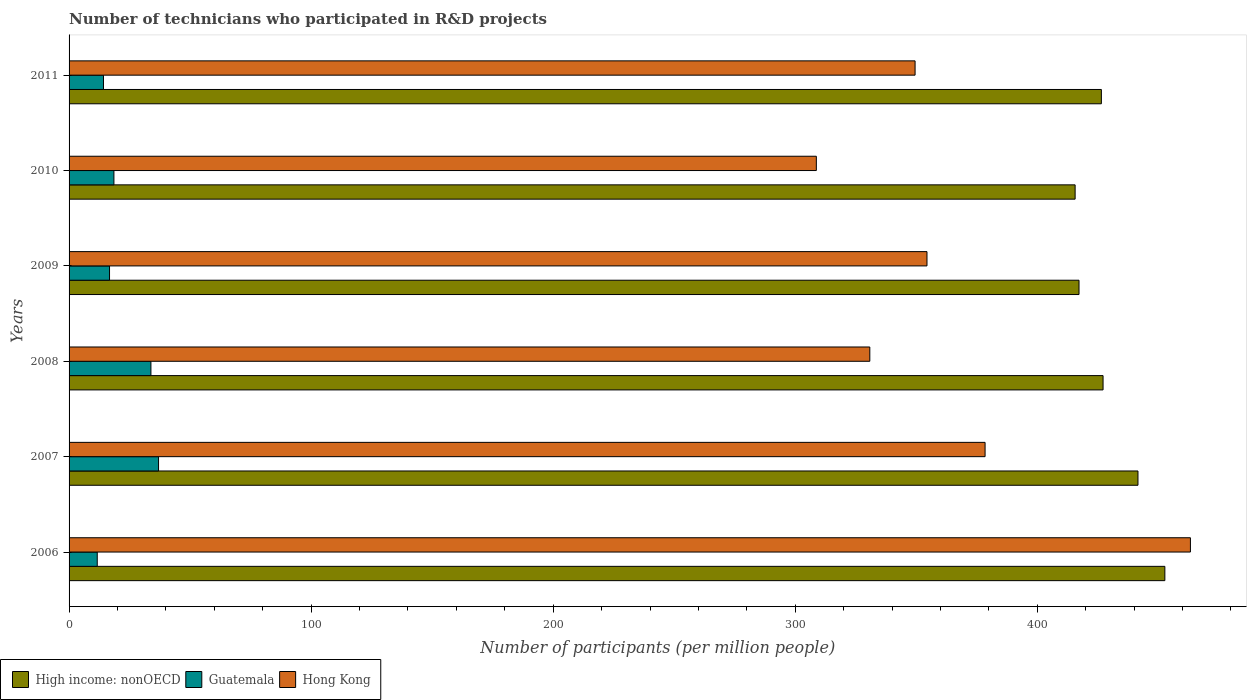Are the number of bars per tick equal to the number of legend labels?
Provide a short and direct response. Yes. How many bars are there on the 2nd tick from the top?
Give a very brief answer. 3. How many bars are there on the 5th tick from the bottom?
Keep it short and to the point. 3. What is the label of the 1st group of bars from the top?
Offer a terse response. 2011. In how many cases, is the number of bars for a given year not equal to the number of legend labels?
Your response must be concise. 0. What is the number of technicians who participated in R&D projects in Hong Kong in 2008?
Ensure brevity in your answer.  330.81. Across all years, what is the maximum number of technicians who participated in R&D projects in Hong Kong?
Your answer should be compact. 463.26. Across all years, what is the minimum number of technicians who participated in R&D projects in High income: nonOECD?
Give a very brief answer. 415.62. In which year was the number of technicians who participated in R&D projects in Hong Kong minimum?
Offer a very short reply. 2010. What is the total number of technicians who participated in R&D projects in High income: nonOECD in the graph?
Ensure brevity in your answer.  2580.78. What is the difference between the number of technicians who participated in R&D projects in Hong Kong in 2007 and that in 2011?
Offer a very short reply. 28.92. What is the difference between the number of technicians who participated in R&D projects in Hong Kong in 2009 and the number of technicians who participated in R&D projects in Guatemala in 2007?
Provide a short and direct response. 317.46. What is the average number of technicians who participated in R&D projects in High income: nonOECD per year?
Provide a succinct answer. 430.13. In the year 2009, what is the difference between the number of technicians who participated in R&D projects in Guatemala and number of technicians who participated in R&D projects in Hong Kong?
Ensure brevity in your answer.  -337.71. In how many years, is the number of technicians who participated in R&D projects in High income: nonOECD greater than 220 ?
Offer a terse response. 6. What is the ratio of the number of technicians who participated in R&D projects in High income: nonOECD in 2009 to that in 2011?
Your answer should be very brief. 0.98. Is the number of technicians who participated in R&D projects in Hong Kong in 2007 less than that in 2011?
Your answer should be compact. No. Is the difference between the number of technicians who participated in R&D projects in Guatemala in 2009 and 2010 greater than the difference between the number of technicians who participated in R&D projects in Hong Kong in 2009 and 2010?
Provide a short and direct response. No. What is the difference between the highest and the second highest number of technicians who participated in R&D projects in Guatemala?
Provide a succinct answer. 3.15. What is the difference between the highest and the lowest number of technicians who participated in R&D projects in High income: nonOECD?
Give a very brief answer. 37.07. What does the 1st bar from the top in 2006 represents?
Your response must be concise. Hong Kong. What does the 1st bar from the bottom in 2006 represents?
Offer a terse response. High income: nonOECD. Is it the case that in every year, the sum of the number of technicians who participated in R&D projects in High income: nonOECD and number of technicians who participated in R&D projects in Guatemala is greater than the number of technicians who participated in R&D projects in Hong Kong?
Offer a very short reply. Yes. Are all the bars in the graph horizontal?
Offer a very short reply. Yes. Are the values on the major ticks of X-axis written in scientific E-notation?
Give a very brief answer. No. Does the graph contain grids?
Offer a terse response. No. How many legend labels are there?
Your answer should be very brief. 3. What is the title of the graph?
Offer a terse response. Number of technicians who participated in R&D projects. What is the label or title of the X-axis?
Your response must be concise. Number of participants (per million people). What is the label or title of the Y-axis?
Offer a terse response. Years. What is the Number of participants (per million people) of High income: nonOECD in 2006?
Your answer should be very brief. 452.7. What is the Number of participants (per million people) in Guatemala in 2006?
Make the answer very short. 11.64. What is the Number of participants (per million people) of Hong Kong in 2006?
Your response must be concise. 463.26. What is the Number of participants (per million people) of High income: nonOECD in 2007?
Offer a terse response. 441.59. What is the Number of participants (per million people) in Guatemala in 2007?
Ensure brevity in your answer.  36.96. What is the Number of participants (per million people) in Hong Kong in 2007?
Offer a very short reply. 378.42. What is the Number of participants (per million people) in High income: nonOECD in 2008?
Provide a succinct answer. 427.17. What is the Number of participants (per million people) in Guatemala in 2008?
Your response must be concise. 33.81. What is the Number of participants (per million people) in Hong Kong in 2008?
Your answer should be very brief. 330.81. What is the Number of participants (per million people) of High income: nonOECD in 2009?
Provide a succinct answer. 417.23. What is the Number of participants (per million people) in Guatemala in 2009?
Your answer should be compact. 16.72. What is the Number of participants (per million people) of Hong Kong in 2009?
Make the answer very short. 354.43. What is the Number of participants (per million people) of High income: nonOECD in 2010?
Your answer should be very brief. 415.62. What is the Number of participants (per million people) of Guatemala in 2010?
Ensure brevity in your answer.  18.53. What is the Number of participants (per million people) of Hong Kong in 2010?
Offer a very short reply. 308.71. What is the Number of participants (per million people) in High income: nonOECD in 2011?
Offer a terse response. 426.47. What is the Number of participants (per million people) of Guatemala in 2011?
Your answer should be very brief. 14.22. What is the Number of participants (per million people) of Hong Kong in 2011?
Your answer should be compact. 349.51. Across all years, what is the maximum Number of participants (per million people) in High income: nonOECD?
Provide a short and direct response. 452.7. Across all years, what is the maximum Number of participants (per million people) in Guatemala?
Your response must be concise. 36.96. Across all years, what is the maximum Number of participants (per million people) in Hong Kong?
Offer a terse response. 463.26. Across all years, what is the minimum Number of participants (per million people) of High income: nonOECD?
Your answer should be compact. 415.62. Across all years, what is the minimum Number of participants (per million people) of Guatemala?
Your answer should be very brief. 11.64. Across all years, what is the minimum Number of participants (per million people) in Hong Kong?
Your answer should be compact. 308.71. What is the total Number of participants (per million people) of High income: nonOECD in the graph?
Make the answer very short. 2580.78. What is the total Number of participants (per million people) of Guatemala in the graph?
Your answer should be compact. 131.88. What is the total Number of participants (per million people) in Hong Kong in the graph?
Provide a succinct answer. 2185.13. What is the difference between the Number of participants (per million people) of High income: nonOECD in 2006 and that in 2007?
Provide a short and direct response. 11.11. What is the difference between the Number of participants (per million people) of Guatemala in 2006 and that in 2007?
Ensure brevity in your answer.  -25.32. What is the difference between the Number of participants (per million people) in Hong Kong in 2006 and that in 2007?
Provide a short and direct response. 84.83. What is the difference between the Number of participants (per million people) in High income: nonOECD in 2006 and that in 2008?
Ensure brevity in your answer.  25.53. What is the difference between the Number of participants (per million people) in Guatemala in 2006 and that in 2008?
Offer a terse response. -22.18. What is the difference between the Number of participants (per million people) of Hong Kong in 2006 and that in 2008?
Offer a terse response. 132.45. What is the difference between the Number of participants (per million people) in High income: nonOECD in 2006 and that in 2009?
Offer a very short reply. 35.46. What is the difference between the Number of participants (per million people) in Guatemala in 2006 and that in 2009?
Your response must be concise. -5.08. What is the difference between the Number of participants (per million people) of Hong Kong in 2006 and that in 2009?
Your response must be concise. 108.83. What is the difference between the Number of participants (per million people) in High income: nonOECD in 2006 and that in 2010?
Offer a terse response. 37.07. What is the difference between the Number of participants (per million people) of Guatemala in 2006 and that in 2010?
Make the answer very short. -6.89. What is the difference between the Number of participants (per million people) in Hong Kong in 2006 and that in 2010?
Provide a short and direct response. 154.54. What is the difference between the Number of participants (per million people) of High income: nonOECD in 2006 and that in 2011?
Provide a short and direct response. 26.23. What is the difference between the Number of participants (per million people) in Guatemala in 2006 and that in 2011?
Your response must be concise. -2.58. What is the difference between the Number of participants (per million people) in Hong Kong in 2006 and that in 2011?
Offer a very short reply. 113.75. What is the difference between the Number of participants (per million people) in High income: nonOECD in 2007 and that in 2008?
Your answer should be compact. 14.42. What is the difference between the Number of participants (per million people) in Guatemala in 2007 and that in 2008?
Provide a succinct answer. 3.15. What is the difference between the Number of participants (per million people) of Hong Kong in 2007 and that in 2008?
Make the answer very short. 47.62. What is the difference between the Number of participants (per million people) of High income: nonOECD in 2007 and that in 2009?
Your response must be concise. 24.35. What is the difference between the Number of participants (per million people) in Guatemala in 2007 and that in 2009?
Offer a terse response. 20.25. What is the difference between the Number of participants (per million people) in Hong Kong in 2007 and that in 2009?
Provide a short and direct response. 24. What is the difference between the Number of participants (per million people) of High income: nonOECD in 2007 and that in 2010?
Offer a terse response. 25.96. What is the difference between the Number of participants (per million people) of Guatemala in 2007 and that in 2010?
Provide a short and direct response. 18.43. What is the difference between the Number of participants (per million people) of Hong Kong in 2007 and that in 2010?
Provide a succinct answer. 69.71. What is the difference between the Number of participants (per million people) in High income: nonOECD in 2007 and that in 2011?
Offer a terse response. 15.12. What is the difference between the Number of participants (per million people) in Guatemala in 2007 and that in 2011?
Your answer should be very brief. 22.74. What is the difference between the Number of participants (per million people) in Hong Kong in 2007 and that in 2011?
Provide a short and direct response. 28.92. What is the difference between the Number of participants (per million people) in High income: nonOECD in 2008 and that in 2009?
Offer a very short reply. 9.93. What is the difference between the Number of participants (per million people) of Guatemala in 2008 and that in 2009?
Provide a succinct answer. 17.1. What is the difference between the Number of participants (per million people) in Hong Kong in 2008 and that in 2009?
Your answer should be compact. -23.62. What is the difference between the Number of participants (per million people) of High income: nonOECD in 2008 and that in 2010?
Your response must be concise. 11.54. What is the difference between the Number of participants (per million people) of Guatemala in 2008 and that in 2010?
Provide a short and direct response. 15.28. What is the difference between the Number of participants (per million people) of Hong Kong in 2008 and that in 2010?
Provide a short and direct response. 22.09. What is the difference between the Number of participants (per million people) of High income: nonOECD in 2008 and that in 2011?
Your answer should be compact. 0.7. What is the difference between the Number of participants (per million people) of Guatemala in 2008 and that in 2011?
Keep it short and to the point. 19.59. What is the difference between the Number of participants (per million people) of Hong Kong in 2008 and that in 2011?
Your answer should be very brief. -18.7. What is the difference between the Number of participants (per million people) in High income: nonOECD in 2009 and that in 2010?
Ensure brevity in your answer.  1.61. What is the difference between the Number of participants (per million people) in Guatemala in 2009 and that in 2010?
Offer a terse response. -1.82. What is the difference between the Number of participants (per million people) in Hong Kong in 2009 and that in 2010?
Ensure brevity in your answer.  45.71. What is the difference between the Number of participants (per million people) in High income: nonOECD in 2009 and that in 2011?
Keep it short and to the point. -9.23. What is the difference between the Number of participants (per million people) of Guatemala in 2009 and that in 2011?
Your response must be concise. 2.5. What is the difference between the Number of participants (per million people) in Hong Kong in 2009 and that in 2011?
Your answer should be compact. 4.92. What is the difference between the Number of participants (per million people) of High income: nonOECD in 2010 and that in 2011?
Provide a short and direct response. -10.84. What is the difference between the Number of participants (per million people) in Guatemala in 2010 and that in 2011?
Provide a short and direct response. 4.31. What is the difference between the Number of participants (per million people) in Hong Kong in 2010 and that in 2011?
Provide a short and direct response. -40.79. What is the difference between the Number of participants (per million people) of High income: nonOECD in 2006 and the Number of participants (per million people) of Guatemala in 2007?
Provide a short and direct response. 415.73. What is the difference between the Number of participants (per million people) in High income: nonOECD in 2006 and the Number of participants (per million people) in Hong Kong in 2007?
Offer a very short reply. 74.28. What is the difference between the Number of participants (per million people) of Guatemala in 2006 and the Number of participants (per million people) of Hong Kong in 2007?
Keep it short and to the point. -366.78. What is the difference between the Number of participants (per million people) in High income: nonOECD in 2006 and the Number of participants (per million people) in Guatemala in 2008?
Your answer should be very brief. 418.88. What is the difference between the Number of participants (per million people) in High income: nonOECD in 2006 and the Number of participants (per million people) in Hong Kong in 2008?
Your answer should be very brief. 121.89. What is the difference between the Number of participants (per million people) of Guatemala in 2006 and the Number of participants (per million people) of Hong Kong in 2008?
Keep it short and to the point. -319.17. What is the difference between the Number of participants (per million people) in High income: nonOECD in 2006 and the Number of participants (per million people) in Guatemala in 2009?
Offer a terse response. 435.98. What is the difference between the Number of participants (per million people) of High income: nonOECD in 2006 and the Number of participants (per million people) of Hong Kong in 2009?
Provide a short and direct response. 98.27. What is the difference between the Number of participants (per million people) in Guatemala in 2006 and the Number of participants (per million people) in Hong Kong in 2009?
Make the answer very short. -342.79. What is the difference between the Number of participants (per million people) in High income: nonOECD in 2006 and the Number of participants (per million people) in Guatemala in 2010?
Offer a terse response. 434.17. What is the difference between the Number of participants (per million people) in High income: nonOECD in 2006 and the Number of participants (per million people) in Hong Kong in 2010?
Your answer should be compact. 143.98. What is the difference between the Number of participants (per million people) of Guatemala in 2006 and the Number of participants (per million people) of Hong Kong in 2010?
Your answer should be very brief. -297.07. What is the difference between the Number of participants (per million people) in High income: nonOECD in 2006 and the Number of participants (per million people) in Guatemala in 2011?
Give a very brief answer. 438.48. What is the difference between the Number of participants (per million people) of High income: nonOECD in 2006 and the Number of participants (per million people) of Hong Kong in 2011?
Offer a very short reply. 103.19. What is the difference between the Number of participants (per million people) of Guatemala in 2006 and the Number of participants (per million people) of Hong Kong in 2011?
Offer a terse response. -337.87. What is the difference between the Number of participants (per million people) of High income: nonOECD in 2007 and the Number of participants (per million people) of Guatemala in 2008?
Ensure brevity in your answer.  407.77. What is the difference between the Number of participants (per million people) of High income: nonOECD in 2007 and the Number of participants (per million people) of Hong Kong in 2008?
Keep it short and to the point. 110.78. What is the difference between the Number of participants (per million people) in Guatemala in 2007 and the Number of participants (per million people) in Hong Kong in 2008?
Make the answer very short. -293.84. What is the difference between the Number of participants (per million people) of High income: nonOECD in 2007 and the Number of participants (per million people) of Guatemala in 2009?
Your response must be concise. 424.87. What is the difference between the Number of participants (per million people) in High income: nonOECD in 2007 and the Number of participants (per million people) in Hong Kong in 2009?
Offer a terse response. 87.16. What is the difference between the Number of participants (per million people) of Guatemala in 2007 and the Number of participants (per million people) of Hong Kong in 2009?
Your answer should be very brief. -317.46. What is the difference between the Number of participants (per million people) in High income: nonOECD in 2007 and the Number of participants (per million people) in Guatemala in 2010?
Give a very brief answer. 423.05. What is the difference between the Number of participants (per million people) in High income: nonOECD in 2007 and the Number of participants (per million people) in Hong Kong in 2010?
Your answer should be very brief. 132.87. What is the difference between the Number of participants (per million people) in Guatemala in 2007 and the Number of participants (per million people) in Hong Kong in 2010?
Ensure brevity in your answer.  -271.75. What is the difference between the Number of participants (per million people) of High income: nonOECD in 2007 and the Number of participants (per million people) of Guatemala in 2011?
Ensure brevity in your answer.  427.37. What is the difference between the Number of participants (per million people) of High income: nonOECD in 2007 and the Number of participants (per million people) of Hong Kong in 2011?
Keep it short and to the point. 92.08. What is the difference between the Number of participants (per million people) of Guatemala in 2007 and the Number of participants (per million people) of Hong Kong in 2011?
Keep it short and to the point. -312.54. What is the difference between the Number of participants (per million people) of High income: nonOECD in 2008 and the Number of participants (per million people) of Guatemala in 2009?
Keep it short and to the point. 410.45. What is the difference between the Number of participants (per million people) in High income: nonOECD in 2008 and the Number of participants (per million people) in Hong Kong in 2009?
Ensure brevity in your answer.  72.74. What is the difference between the Number of participants (per million people) of Guatemala in 2008 and the Number of participants (per million people) of Hong Kong in 2009?
Make the answer very short. -320.61. What is the difference between the Number of participants (per million people) of High income: nonOECD in 2008 and the Number of participants (per million people) of Guatemala in 2010?
Keep it short and to the point. 408.64. What is the difference between the Number of participants (per million people) of High income: nonOECD in 2008 and the Number of participants (per million people) of Hong Kong in 2010?
Provide a short and direct response. 118.46. What is the difference between the Number of participants (per million people) of Guatemala in 2008 and the Number of participants (per million people) of Hong Kong in 2010?
Make the answer very short. -274.9. What is the difference between the Number of participants (per million people) in High income: nonOECD in 2008 and the Number of participants (per million people) in Guatemala in 2011?
Offer a terse response. 412.95. What is the difference between the Number of participants (per million people) in High income: nonOECD in 2008 and the Number of participants (per million people) in Hong Kong in 2011?
Keep it short and to the point. 77.66. What is the difference between the Number of participants (per million people) of Guatemala in 2008 and the Number of participants (per million people) of Hong Kong in 2011?
Provide a succinct answer. -315.69. What is the difference between the Number of participants (per million people) in High income: nonOECD in 2009 and the Number of participants (per million people) in Guatemala in 2010?
Your answer should be very brief. 398.7. What is the difference between the Number of participants (per million people) in High income: nonOECD in 2009 and the Number of participants (per million people) in Hong Kong in 2010?
Your answer should be compact. 108.52. What is the difference between the Number of participants (per million people) in Guatemala in 2009 and the Number of participants (per million people) in Hong Kong in 2010?
Keep it short and to the point. -292. What is the difference between the Number of participants (per million people) in High income: nonOECD in 2009 and the Number of participants (per million people) in Guatemala in 2011?
Give a very brief answer. 403.01. What is the difference between the Number of participants (per million people) in High income: nonOECD in 2009 and the Number of participants (per million people) in Hong Kong in 2011?
Give a very brief answer. 67.73. What is the difference between the Number of participants (per million people) of Guatemala in 2009 and the Number of participants (per million people) of Hong Kong in 2011?
Give a very brief answer. -332.79. What is the difference between the Number of participants (per million people) of High income: nonOECD in 2010 and the Number of participants (per million people) of Guatemala in 2011?
Make the answer very short. 401.4. What is the difference between the Number of participants (per million people) of High income: nonOECD in 2010 and the Number of participants (per million people) of Hong Kong in 2011?
Offer a very short reply. 66.12. What is the difference between the Number of participants (per million people) of Guatemala in 2010 and the Number of participants (per million people) of Hong Kong in 2011?
Provide a succinct answer. -330.98. What is the average Number of participants (per million people) of High income: nonOECD per year?
Provide a succinct answer. 430.13. What is the average Number of participants (per million people) of Guatemala per year?
Ensure brevity in your answer.  21.98. What is the average Number of participants (per million people) of Hong Kong per year?
Your answer should be compact. 364.19. In the year 2006, what is the difference between the Number of participants (per million people) of High income: nonOECD and Number of participants (per million people) of Guatemala?
Your answer should be very brief. 441.06. In the year 2006, what is the difference between the Number of participants (per million people) in High income: nonOECD and Number of participants (per million people) in Hong Kong?
Offer a very short reply. -10.56. In the year 2006, what is the difference between the Number of participants (per million people) in Guatemala and Number of participants (per million people) in Hong Kong?
Offer a very short reply. -451.62. In the year 2007, what is the difference between the Number of participants (per million people) of High income: nonOECD and Number of participants (per million people) of Guatemala?
Make the answer very short. 404.62. In the year 2007, what is the difference between the Number of participants (per million people) in High income: nonOECD and Number of participants (per million people) in Hong Kong?
Provide a succinct answer. 63.16. In the year 2007, what is the difference between the Number of participants (per million people) of Guatemala and Number of participants (per million people) of Hong Kong?
Your answer should be compact. -341.46. In the year 2008, what is the difference between the Number of participants (per million people) of High income: nonOECD and Number of participants (per million people) of Guatemala?
Ensure brevity in your answer.  393.35. In the year 2008, what is the difference between the Number of participants (per million people) in High income: nonOECD and Number of participants (per million people) in Hong Kong?
Provide a succinct answer. 96.36. In the year 2008, what is the difference between the Number of participants (per million people) of Guatemala and Number of participants (per million people) of Hong Kong?
Offer a very short reply. -296.99. In the year 2009, what is the difference between the Number of participants (per million people) in High income: nonOECD and Number of participants (per million people) in Guatemala?
Offer a terse response. 400.52. In the year 2009, what is the difference between the Number of participants (per million people) of High income: nonOECD and Number of participants (per million people) of Hong Kong?
Ensure brevity in your answer.  62.81. In the year 2009, what is the difference between the Number of participants (per million people) of Guatemala and Number of participants (per million people) of Hong Kong?
Keep it short and to the point. -337.71. In the year 2010, what is the difference between the Number of participants (per million people) of High income: nonOECD and Number of participants (per million people) of Guatemala?
Your response must be concise. 397.09. In the year 2010, what is the difference between the Number of participants (per million people) in High income: nonOECD and Number of participants (per million people) in Hong Kong?
Provide a succinct answer. 106.91. In the year 2010, what is the difference between the Number of participants (per million people) of Guatemala and Number of participants (per million people) of Hong Kong?
Ensure brevity in your answer.  -290.18. In the year 2011, what is the difference between the Number of participants (per million people) of High income: nonOECD and Number of participants (per million people) of Guatemala?
Provide a succinct answer. 412.25. In the year 2011, what is the difference between the Number of participants (per million people) of High income: nonOECD and Number of participants (per million people) of Hong Kong?
Your answer should be compact. 76.96. In the year 2011, what is the difference between the Number of participants (per million people) in Guatemala and Number of participants (per million people) in Hong Kong?
Ensure brevity in your answer.  -335.29. What is the ratio of the Number of participants (per million people) of High income: nonOECD in 2006 to that in 2007?
Offer a terse response. 1.03. What is the ratio of the Number of participants (per million people) in Guatemala in 2006 to that in 2007?
Offer a very short reply. 0.31. What is the ratio of the Number of participants (per million people) in Hong Kong in 2006 to that in 2007?
Offer a very short reply. 1.22. What is the ratio of the Number of participants (per million people) in High income: nonOECD in 2006 to that in 2008?
Provide a short and direct response. 1.06. What is the ratio of the Number of participants (per million people) of Guatemala in 2006 to that in 2008?
Provide a short and direct response. 0.34. What is the ratio of the Number of participants (per million people) in Hong Kong in 2006 to that in 2008?
Your response must be concise. 1.4. What is the ratio of the Number of participants (per million people) of High income: nonOECD in 2006 to that in 2009?
Provide a succinct answer. 1.08. What is the ratio of the Number of participants (per million people) of Guatemala in 2006 to that in 2009?
Your answer should be compact. 0.7. What is the ratio of the Number of participants (per million people) of Hong Kong in 2006 to that in 2009?
Make the answer very short. 1.31. What is the ratio of the Number of participants (per million people) in High income: nonOECD in 2006 to that in 2010?
Make the answer very short. 1.09. What is the ratio of the Number of participants (per million people) in Guatemala in 2006 to that in 2010?
Your answer should be compact. 0.63. What is the ratio of the Number of participants (per million people) in Hong Kong in 2006 to that in 2010?
Offer a terse response. 1.5. What is the ratio of the Number of participants (per million people) of High income: nonOECD in 2006 to that in 2011?
Your response must be concise. 1.06. What is the ratio of the Number of participants (per million people) in Guatemala in 2006 to that in 2011?
Your answer should be very brief. 0.82. What is the ratio of the Number of participants (per million people) in Hong Kong in 2006 to that in 2011?
Make the answer very short. 1.33. What is the ratio of the Number of participants (per million people) of High income: nonOECD in 2007 to that in 2008?
Your response must be concise. 1.03. What is the ratio of the Number of participants (per million people) of Guatemala in 2007 to that in 2008?
Your answer should be compact. 1.09. What is the ratio of the Number of participants (per million people) of Hong Kong in 2007 to that in 2008?
Provide a short and direct response. 1.14. What is the ratio of the Number of participants (per million people) of High income: nonOECD in 2007 to that in 2009?
Your answer should be compact. 1.06. What is the ratio of the Number of participants (per million people) of Guatemala in 2007 to that in 2009?
Give a very brief answer. 2.21. What is the ratio of the Number of participants (per million people) in Hong Kong in 2007 to that in 2009?
Your answer should be compact. 1.07. What is the ratio of the Number of participants (per million people) of Guatemala in 2007 to that in 2010?
Make the answer very short. 1.99. What is the ratio of the Number of participants (per million people) of Hong Kong in 2007 to that in 2010?
Your answer should be compact. 1.23. What is the ratio of the Number of participants (per million people) in High income: nonOECD in 2007 to that in 2011?
Give a very brief answer. 1.04. What is the ratio of the Number of participants (per million people) of Guatemala in 2007 to that in 2011?
Give a very brief answer. 2.6. What is the ratio of the Number of participants (per million people) in Hong Kong in 2007 to that in 2011?
Offer a terse response. 1.08. What is the ratio of the Number of participants (per million people) in High income: nonOECD in 2008 to that in 2009?
Provide a short and direct response. 1.02. What is the ratio of the Number of participants (per million people) in Guatemala in 2008 to that in 2009?
Your answer should be very brief. 2.02. What is the ratio of the Number of participants (per million people) of Hong Kong in 2008 to that in 2009?
Your answer should be very brief. 0.93. What is the ratio of the Number of participants (per million people) of High income: nonOECD in 2008 to that in 2010?
Provide a short and direct response. 1.03. What is the ratio of the Number of participants (per million people) of Guatemala in 2008 to that in 2010?
Keep it short and to the point. 1.82. What is the ratio of the Number of participants (per million people) in Hong Kong in 2008 to that in 2010?
Provide a succinct answer. 1.07. What is the ratio of the Number of participants (per million people) in Guatemala in 2008 to that in 2011?
Provide a succinct answer. 2.38. What is the ratio of the Number of participants (per million people) of Hong Kong in 2008 to that in 2011?
Keep it short and to the point. 0.95. What is the ratio of the Number of participants (per million people) in High income: nonOECD in 2009 to that in 2010?
Offer a very short reply. 1. What is the ratio of the Number of participants (per million people) in Guatemala in 2009 to that in 2010?
Offer a very short reply. 0.9. What is the ratio of the Number of participants (per million people) in Hong Kong in 2009 to that in 2010?
Keep it short and to the point. 1.15. What is the ratio of the Number of participants (per million people) in High income: nonOECD in 2009 to that in 2011?
Give a very brief answer. 0.98. What is the ratio of the Number of participants (per million people) of Guatemala in 2009 to that in 2011?
Your response must be concise. 1.18. What is the ratio of the Number of participants (per million people) in Hong Kong in 2009 to that in 2011?
Make the answer very short. 1.01. What is the ratio of the Number of participants (per million people) of High income: nonOECD in 2010 to that in 2011?
Offer a terse response. 0.97. What is the ratio of the Number of participants (per million people) in Guatemala in 2010 to that in 2011?
Offer a very short reply. 1.3. What is the ratio of the Number of participants (per million people) of Hong Kong in 2010 to that in 2011?
Your answer should be very brief. 0.88. What is the difference between the highest and the second highest Number of participants (per million people) of High income: nonOECD?
Your answer should be compact. 11.11. What is the difference between the highest and the second highest Number of participants (per million people) in Guatemala?
Your answer should be compact. 3.15. What is the difference between the highest and the second highest Number of participants (per million people) in Hong Kong?
Your answer should be very brief. 84.83. What is the difference between the highest and the lowest Number of participants (per million people) of High income: nonOECD?
Ensure brevity in your answer.  37.07. What is the difference between the highest and the lowest Number of participants (per million people) of Guatemala?
Give a very brief answer. 25.32. What is the difference between the highest and the lowest Number of participants (per million people) of Hong Kong?
Provide a succinct answer. 154.54. 